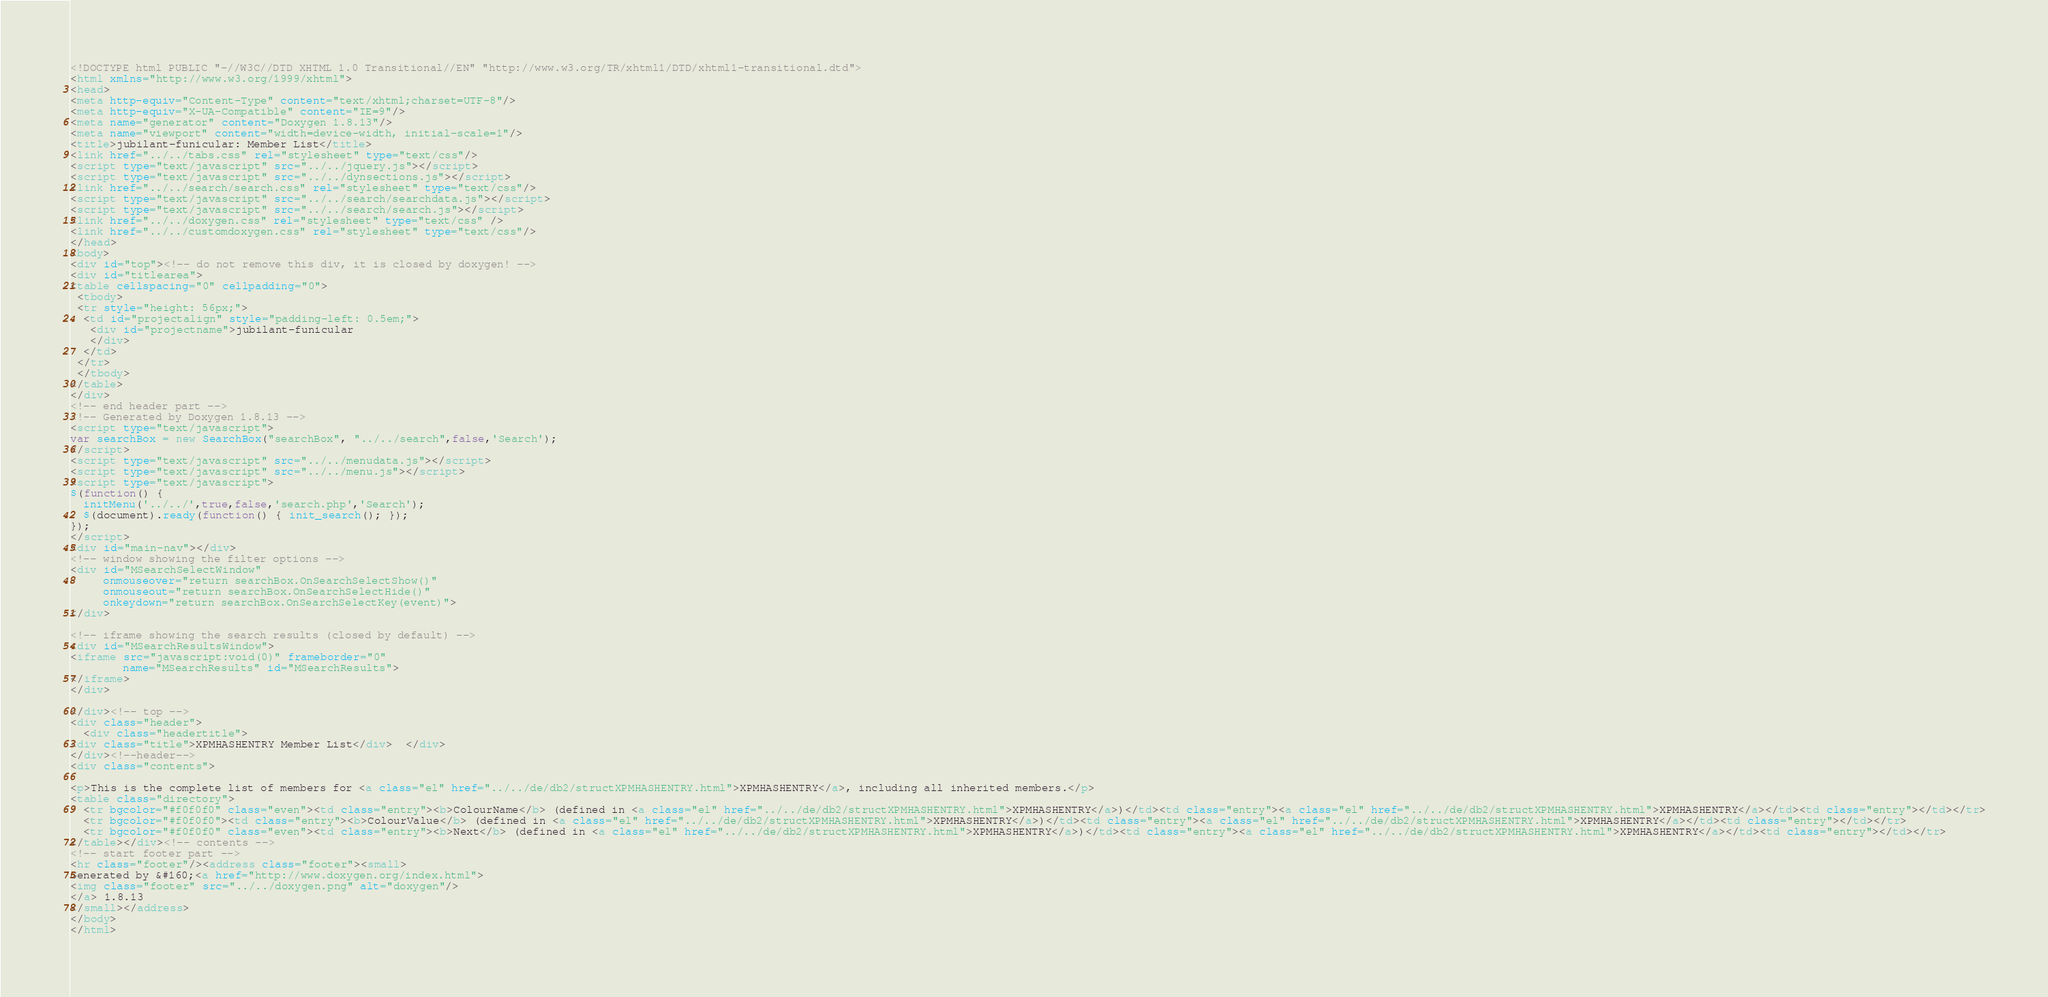<code> <loc_0><loc_0><loc_500><loc_500><_HTML_><!DOCTYPE html PUBLIC "-//W3C//DTD XHTML 1.0 Transitional//EN" "http://www.w3.org/TR/xhtml1/DTD/xhtml1-transitional.dtd">
<html xmlns="http://www.w3.org/1999/xhtml">
<head>
<meta http-equiv="Content-Type" content="text/xhtml;charset=UTF-8"/>
<meta http-equiv="X-UA-Compatible" content="IE=9"/>
<meta name="generator" content="Doxygen 1.8.13"/>
<meta name="viewport" content="width=device-width, initial-scale=1"/>
<title>jubilant-funicular: Member List</title>
<link href="../../tabs.css" rel="stylesheet" type="text/css"/>
<script type="text/javascript" src="../../jquery.js"></script>
<script type="text/javascript" src="../../dynsections.js"></script>
<link href="../../search/search.css" rel="stylesheet" type="text/css"/>
<script type="text/javascript" src="../../search/searchdata.js"></script>
<script type="text/javascript" src="../../search/search.js"></script>
<link href="../../doxygen.css" rel="stylesheet" type="text/css" />
<link href="../../customdoxygen.css" rel="stylesheet" type="text/css"/>
</head>
<body>
<div id="top"><!-- do not remove this div, it is closed by doxygen! -->
<div id="titlearea">
<table cellspacing="0" cellpadding="0">
 <tbody>
 <tr style="height: 56px;">
  <td id="projectalign" style="padding-left: 0.5em;">
   <div id="projectname">jubilant-funicular
   </div>
  </td>
 </tr>
 </tbody>
</table>
</div>
<!-- end header part -->
<!-- Generated by Doxygen 1.8.13 -->
<script type="text/javascript">
var searchBox = new SearchBox("searchBox", "../../search",false,'Search');
</script>
<script type="text/javascript" src="../../menudata.js"></script>
<script type="text/javascript" src="../../menu.js"></script>
<script type="text/javascript">
$(function() {
  initMenu('../../',true,false,'search.php','Search');
  $(document).ready(function() { init_search(); });
});
</script>
<div id="main-nav"></div>
<!-- window showing the filter options -->
<div id="MSearchSelectWindow"
     onmouseover="return searchBox.OnSearchSelectShow()"
     onmouseout="return searchBox.OnSearchSelectHide()"
     onkeydown="return searchBox.OnSearchSelectKey(event)">
</div>

<!-- iframe showing the search results (closed by default) -->
<div id="MSearchResultsWindow">
<iframe src="javascript:void(0)" frameborder="0" 
        name="MSearchResults" id="MSearchResults">
</iframe>
</div>

</div><!-- top -->
<div class="header">
  <div class="headertitle">
<div class="title">XPMHASHENTRY Member List</div>  </div>
</div><!--header-->
<div class="contents">

<p>This is the complete list of members for <a class="el" href="../../de/db2/structXPMHASHENTRY.html">XPMHASHENTRY</a>, including all inherited members.</p>
<table class="directory">
  <tr bgcolor="#f0f0f0" class="even"><td class="entry"><b>ColourName</b> (defined in <a class="el" href="../../de/db2/structXPMHASHENTRY.html">XPMHASHENTRY</a>)</td><td class="entry"><a class="el" href="../../de/db2/structXPMHASHENTRY.html">XPMHASHENTRY</a></td><td class="entry"></td></tr>
  <tr bgcolor="#f0f0f0"><td class="entry"><b>ColourValue</b> (defined in <a class="el" href="../../de/db2/structXPMHASHENTRY.html">XPMHASHENTRY</a>)</td><td class="entry"><a class="el" href="../../de/db2/structXPMHASHENTRY.html">XPMHASHENTRY</a></td><td class="entry"></td></tr>
  <tr bgcolor="#f0f0f0" class="even"><td class="entry"><b>Next</b> (defined in <a class="el" href="../../de/db2/structXPMHASHENTRY.html">XPMHASHENTRY</a>)</td><td class="entry"><a class="el" href="../../de/db2/structXPMHASHENTRY.html">XPMHASHENTRY</a></td><td class="entry"></td></tr>
</table></div><!-- contents -->
<!-- start footer part -->
<hr class="footer"/><address class="footer"><small>
Generated by &#160;<a href="http://www.doxygen.org/index.html">
<img class="footer" src="../../doxygen.png" alt="doxygen"/>
</a> 1.8.13
</small></address>
</body>
</html>
</code> 